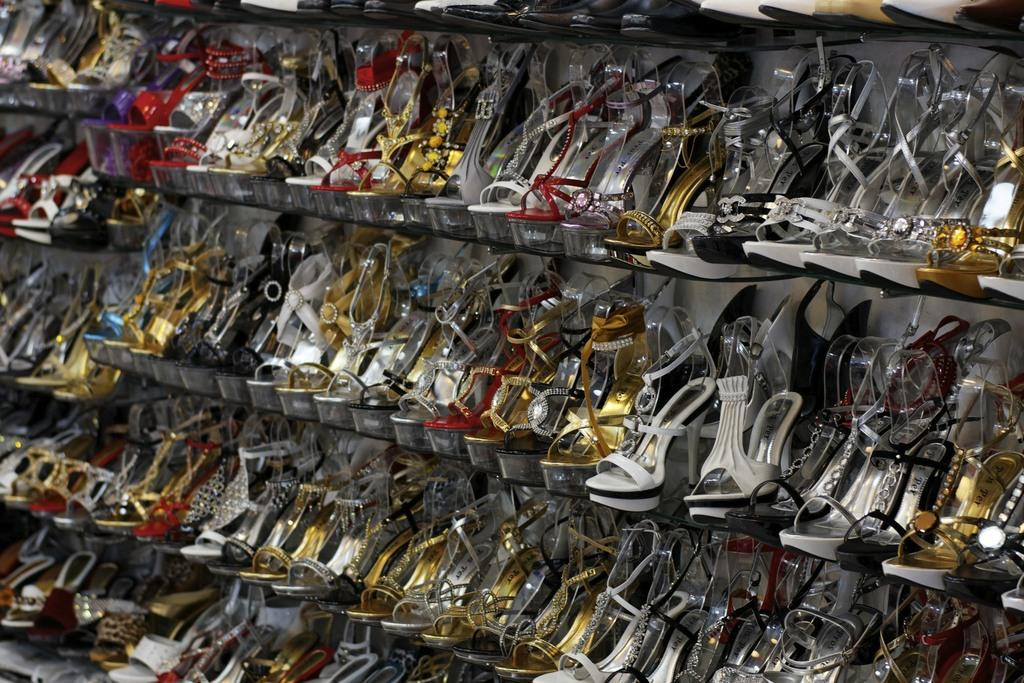What type of object is present in the image? There is footwear in the image. What can be seen behind the footwear? There is a wall behind the footwear. What type of bone is visible in the image? There is no bone present in the image; it features footwear and a wall. What type of tax is being discussed in the image? There is no discussion of taxes in the image; it focuses on footwear and a wall. 